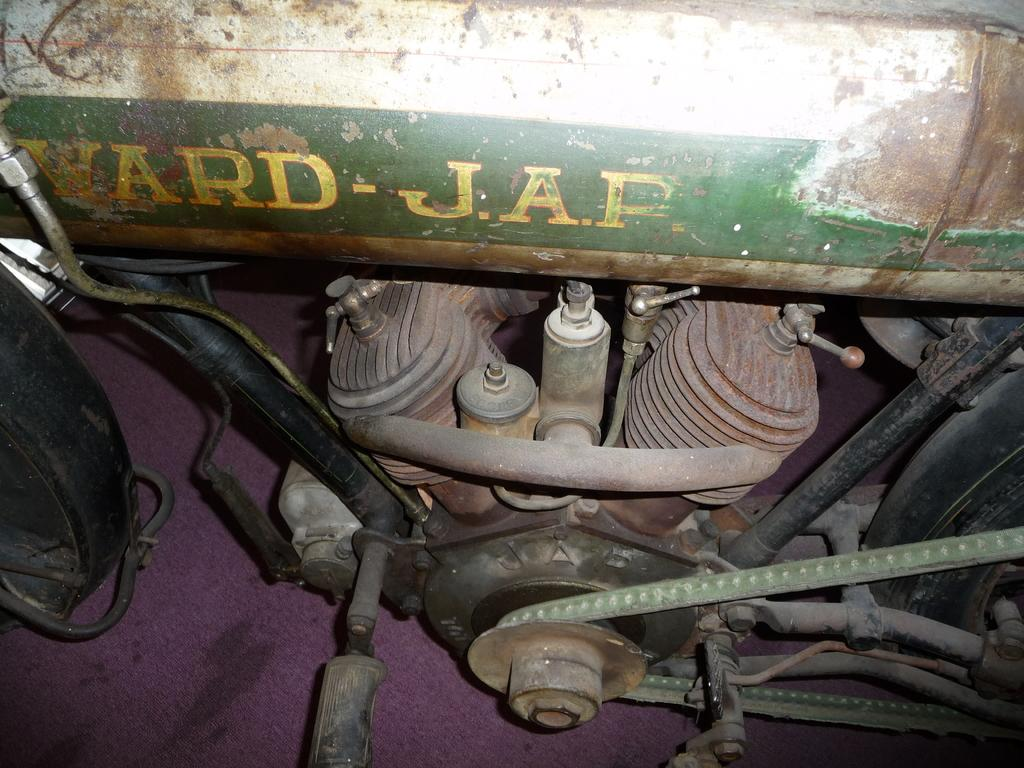What is the main subject of the image? There is a vehicle in the image. What part of the vehicle can be seen at the center of the image? The engine is visible at the center of the image. How many wheels are visible on the left side of the image? There are wheels on the left side of the image. How many wheels are visible on the right side of the image? There are wheels on the right side of the image. What type of throat problem is the driver experiencing in the image? There is no driver present in the image, and therefore no throat problem can be observed. What type of journey is the vehicle taking in the image? The image does not provide any information about the vehicle's journey, so it cannot be determined. 